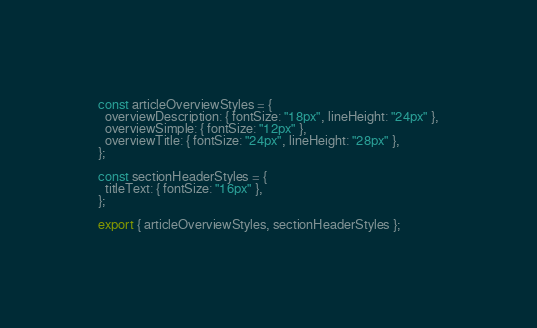Convert code to text. <code><loc_0><loc_0><loc_500><loc_500><_JavaScript_>const articleOverviewStyles = {
  overviewDescription: { fontSize: "18px", lineHeight: "24px" },
  overviewSimple: { fontSize: "12px" },
  overviewTitle: { fontSize: "24px", lineHeight: "28px" },
};

const sectionHeaderStyles = {
  titleText: { fontSize: "16px" },
};

export { articleOverviewStyles, sectionHeaderStyles };
</code> 